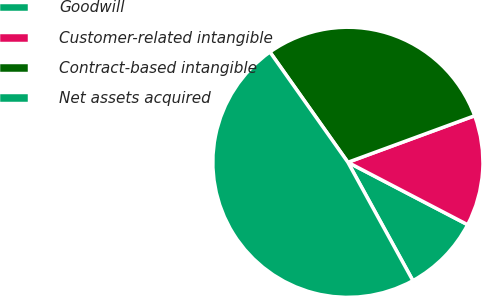Convert chart to OTSL. <chart><loc_0><loc_0><loc_500><loc_500><pie_chart><fcel>Goodwill<fcel>Customer-related intangible<fcel>Contract-based intangible<fcel>Net assets acquired<nl><fcel>9.36%<fcel>13.25%<fcel>29.19%<fcel>48.2%<nl></chart> 